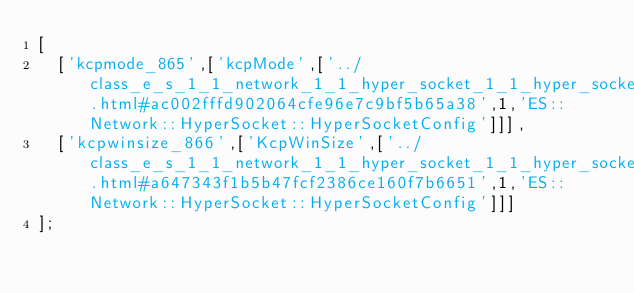Convert code to text. <code><loc_0><loc_0><loc_500><loc_500><_JavaScript_>[
  ['kcpmode_865',['kcpMode',['../class_e_s_1_1_network_1_1_hyper_socket_1_1_hyper_socket_config.html#ac002fffd902064cfe96e7c9bf5b65a38',1,'ES::Network::HyperSocket::HyperSocketConfig']]],
  ['kcpwinsize_866',['KcpWinSize',['../class_e_s_1_1_network_1_1_hyper_socket_1_1_hyper_socket_config.html#a647343f1b5b47fcf2386ce160f7b6651',1,'ES::Network::HyperSocket::HyperSocketConfig']]]
];
</code> 